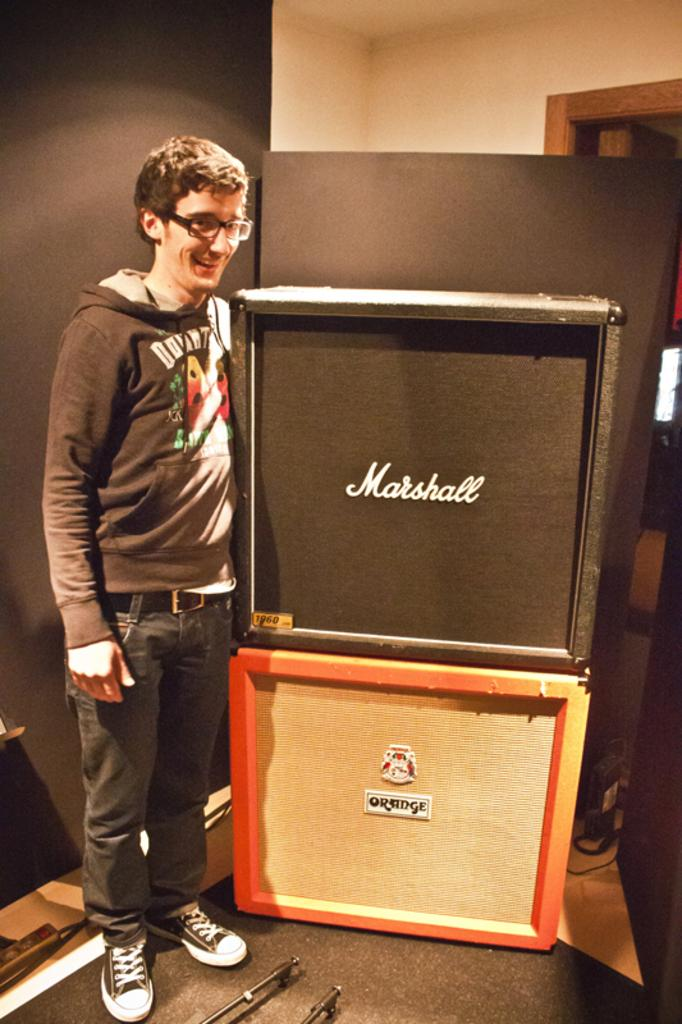Who is present in the image? There is a man in the image. Where is the man located? The man is standing in a room. What can be seen beside the man? There are boxes beside the man. What type of shirt is the man wearing in the image? The provided facts do not mention the type of shirt the man is wearing, so we cannot answer that question. Is there a cobweb visible in the image? There is no mention of a cobweb in the provided facts, so we cannot determine if one is present in the image. 